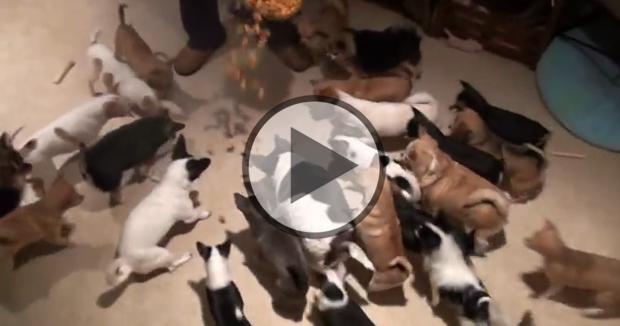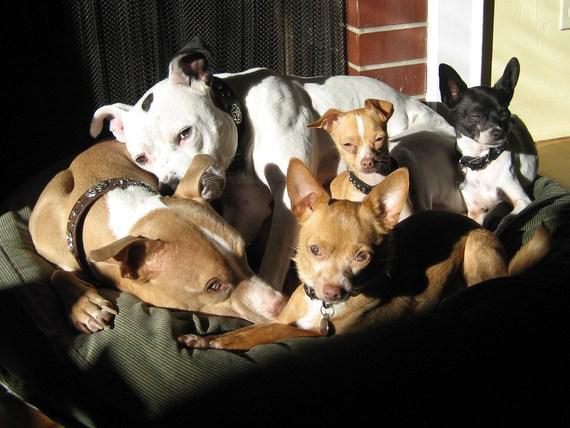The first image is the image on the left, the second image is the image on the right. For the images displayed, is the sentence "There is exactly one animal in one of the images." factually correct? Answer yes or no. No. 